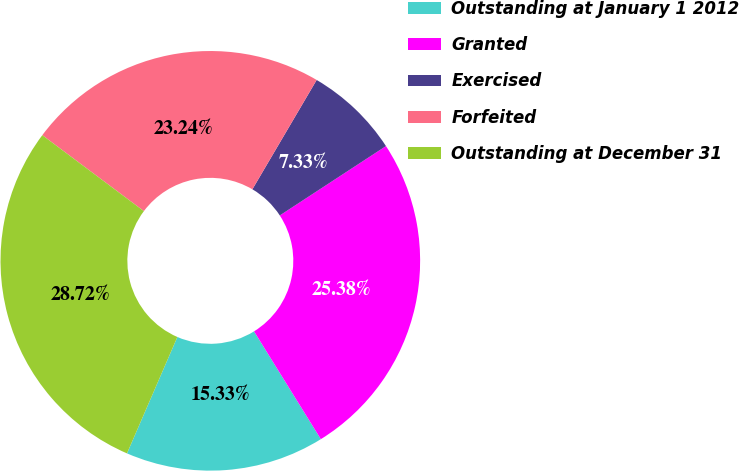Convert chart. <chart><loc_0><loc_0><loc_500><loc_500><pie_chart><fcel>Outstanding at January 1 2012<fcel>Granted<fcel>Exercised<fcel>Forfeited<fcel>Outstanding at December 31<nl><fcel>15.33%<fcel>25.38%<fcel>7.33%<fcel>23.24%<fcel>28.72%<nl></chart> 